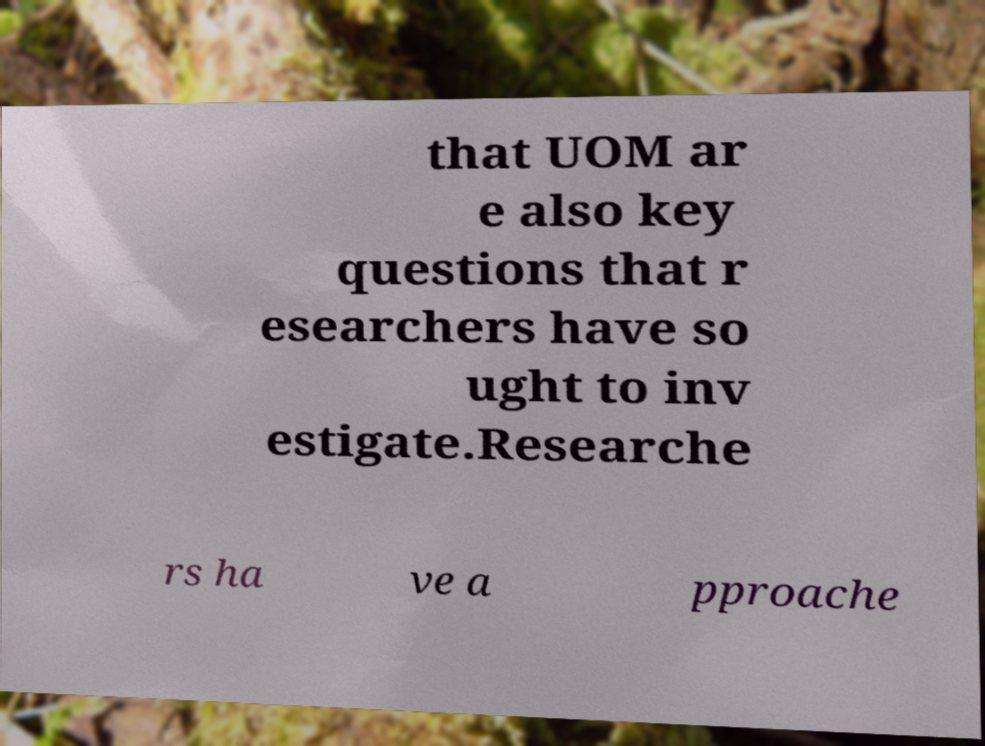What messages or text are displayed in this image? I need them in a readable, typed format. that UOM ar e also key questions that r esearchers have so ught to inv estigate.Researche rs ha ve a pproache 